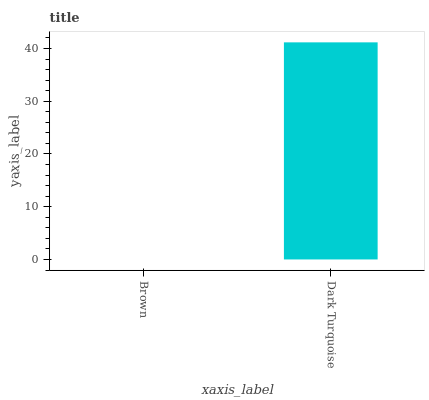Is Dark Turquoise the minimum?
Answer yes or no. No. Is Dark Turquoise greater than Brown?
Answer yes or no. Yes. Is Brown less than Dark Turquoise?
Answer yes or no. Yes. Is Brown greater than Dark Turquoise?
Answer yes or no. No. Is Dark Turquoise less than Brown?
Answer yes or no. No. Is Dark Turquoise the high median?
Answer yes or no. Yes. Is Brown the low median?
Answer yes or no. Yes. Is Brown the high median?
Answer yes or no. No. Is Dark Turquoise the low median?
Answer yes or no. No. 